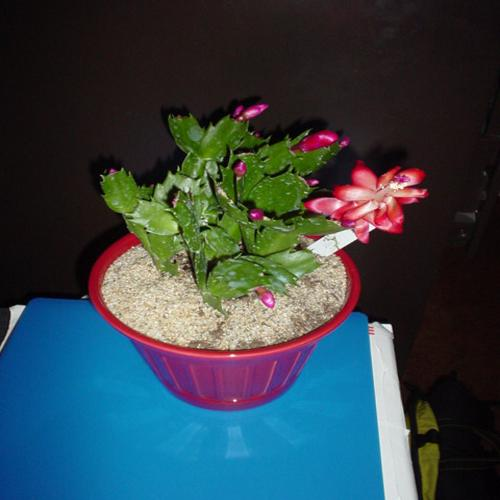What's the significance of the pot's color? The pot's bright red color could be intentionally chosen to complement the vibrant pink blossoms of the Christmas cactus, creating a festive look. Red pots are also visually striking and can enhance the aesthetic appeal of the plant, especially during the holiday season when red is a prominent color in decorations. 